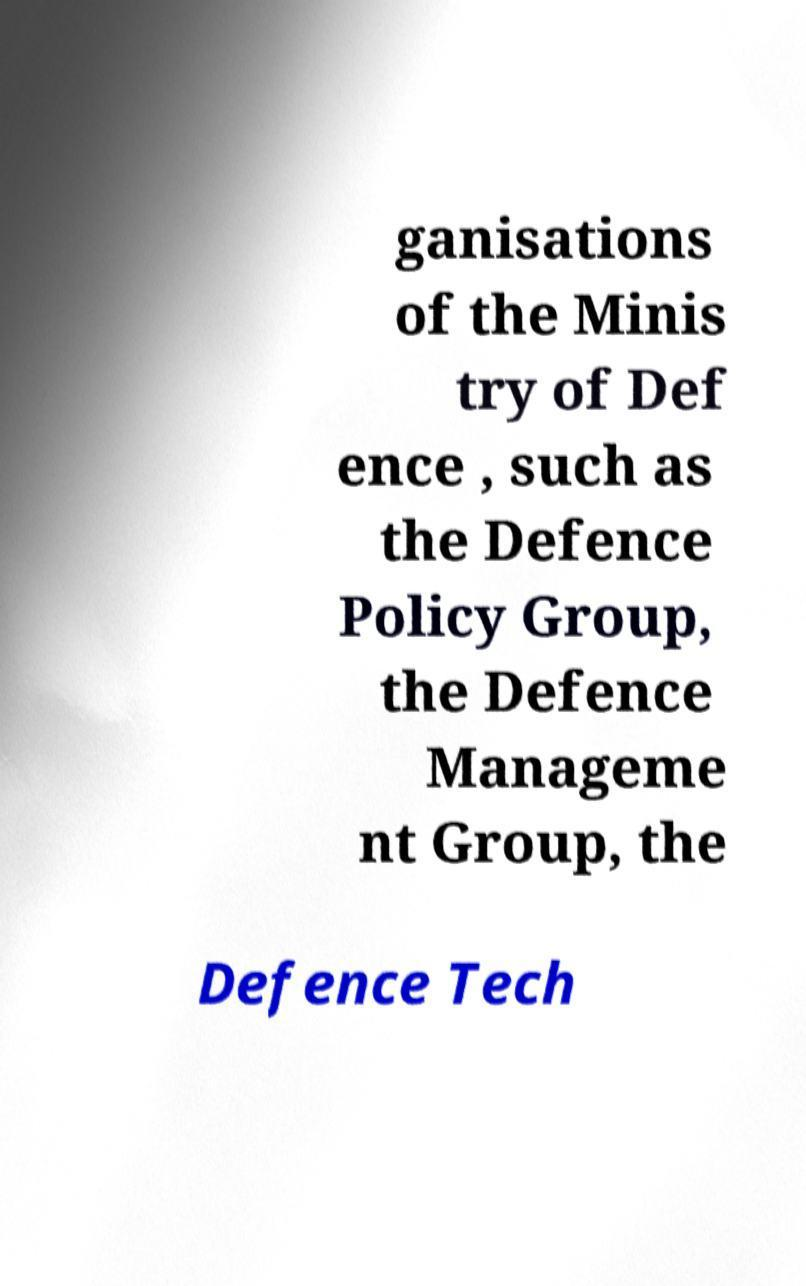What messages or text are displayed in this image? I need them in a readable, typed format. ganisations of the Minis try of Def ence , such as the Defence Policy Group, the Defence Manageme nt Group, the Defence Tech 